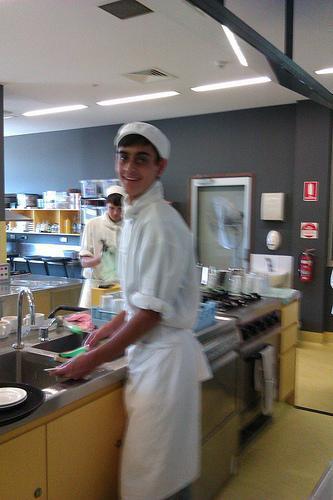How many other people are there?
Give a very brief answer. 1. 